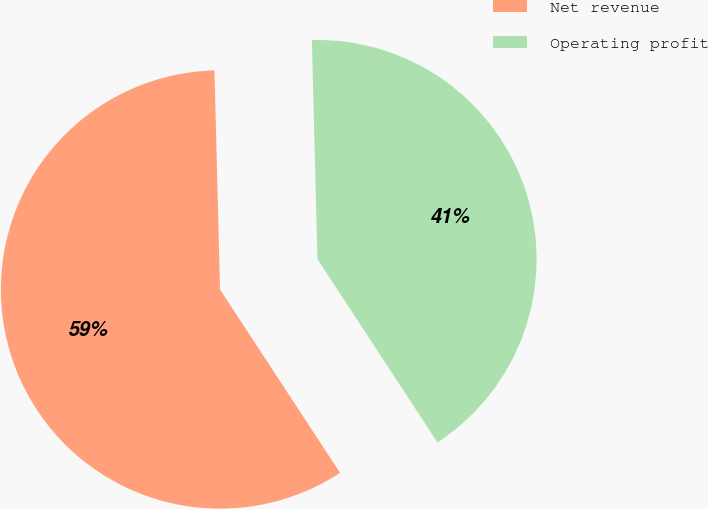Convert chart. <chart><loc_0><loc_0><loc_500><loc_500><pie_chart><fcel>Net revenue<fcel>Operating profit<nl><fcel>58.82%<fcel>41.18%<nl></chart> 